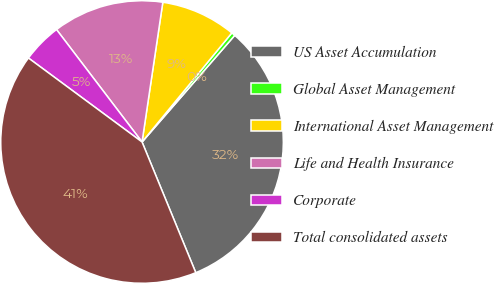<chart> <loc_0><loc_0><loc_500><loc_500><pie_chart><fcel>US Asset Accumulation<fcel>Global Asset Management<fcel>International Asset Management<fcel>Life and Health Insurance<fcel>Corporate<fcel>Total consolidated assets<nl><fcel>32.4%<fcel>0.43%<fcel>8.61%<fcel>12.7%<fcel>4.52%<fcel>41.34%<nl></chart> 